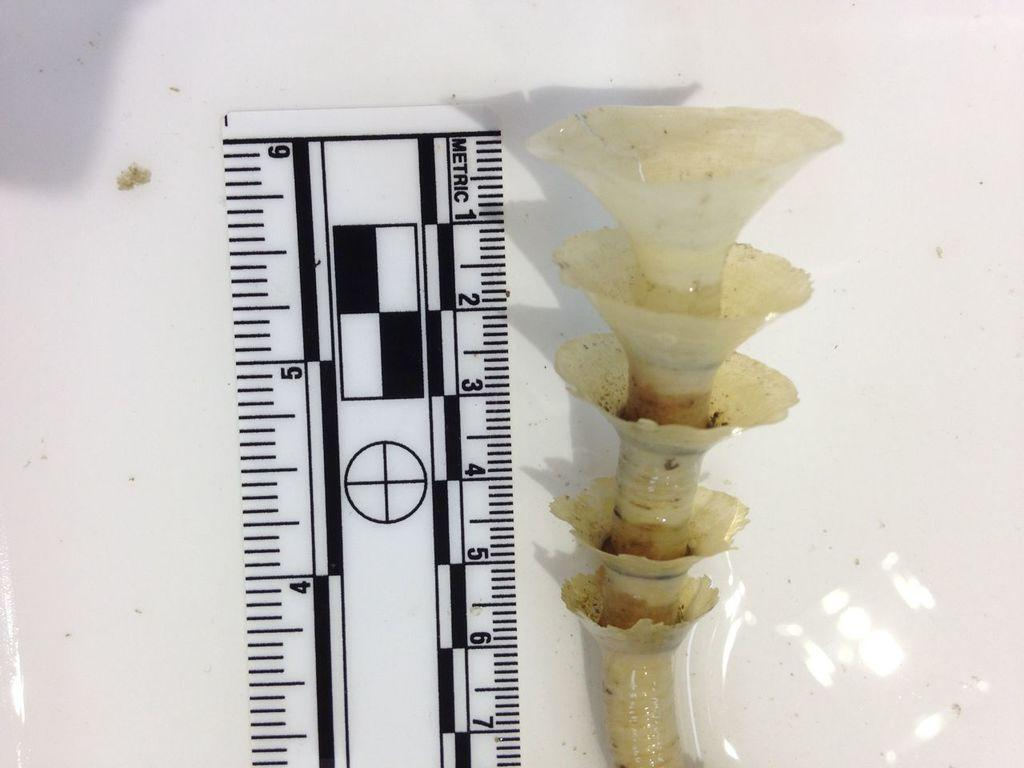<image>
Render a clear and concise summary of the photo. An item is measured against a metric ruler. 